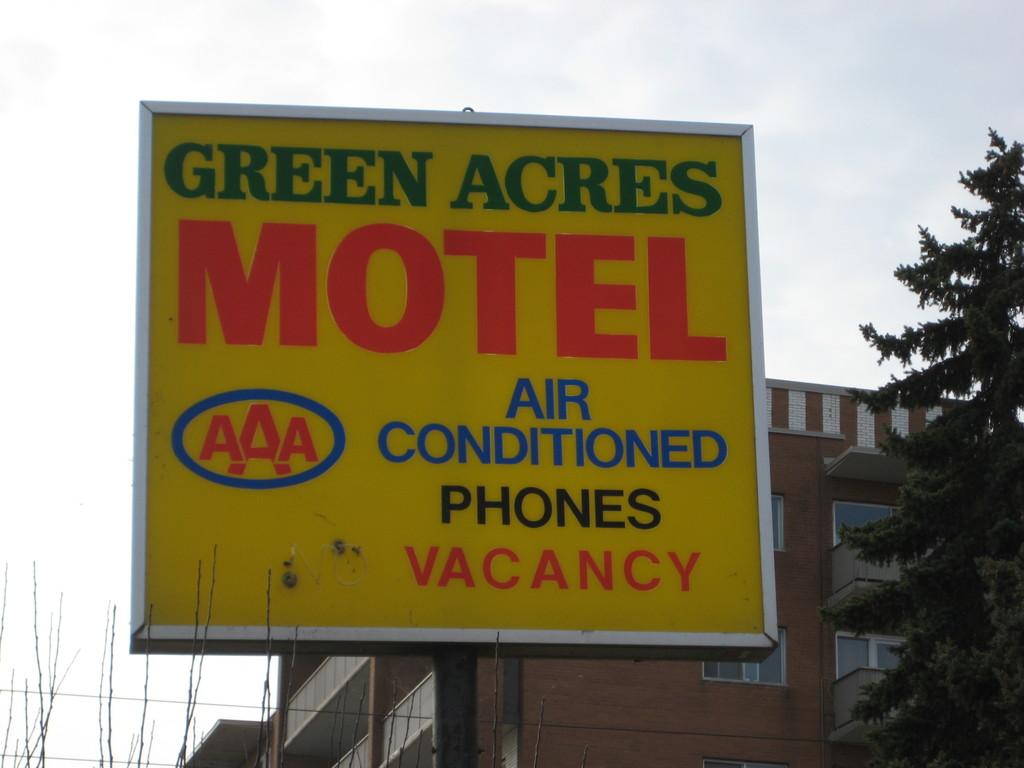What is the name of the motel?
Provide a short and direct response. Green acres. Is there vacancy?
Your answer should be very brief. Yes. 